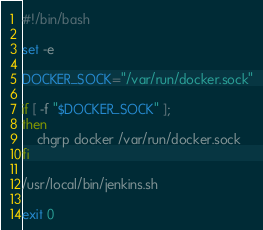Convert code to text. <code><loc_0><loc_0><loc_500><loc_500><_Bash_>#!/bin/bash

set -e

DOCKER_SOCK="/var/run/docker.sock"

if [ -f "$DOCKER_SOCK" ];
then
    chgrp docker /var/run/docker.sock
fi

/usr/local/bin/jenkins.sh

exit 0
</code> 